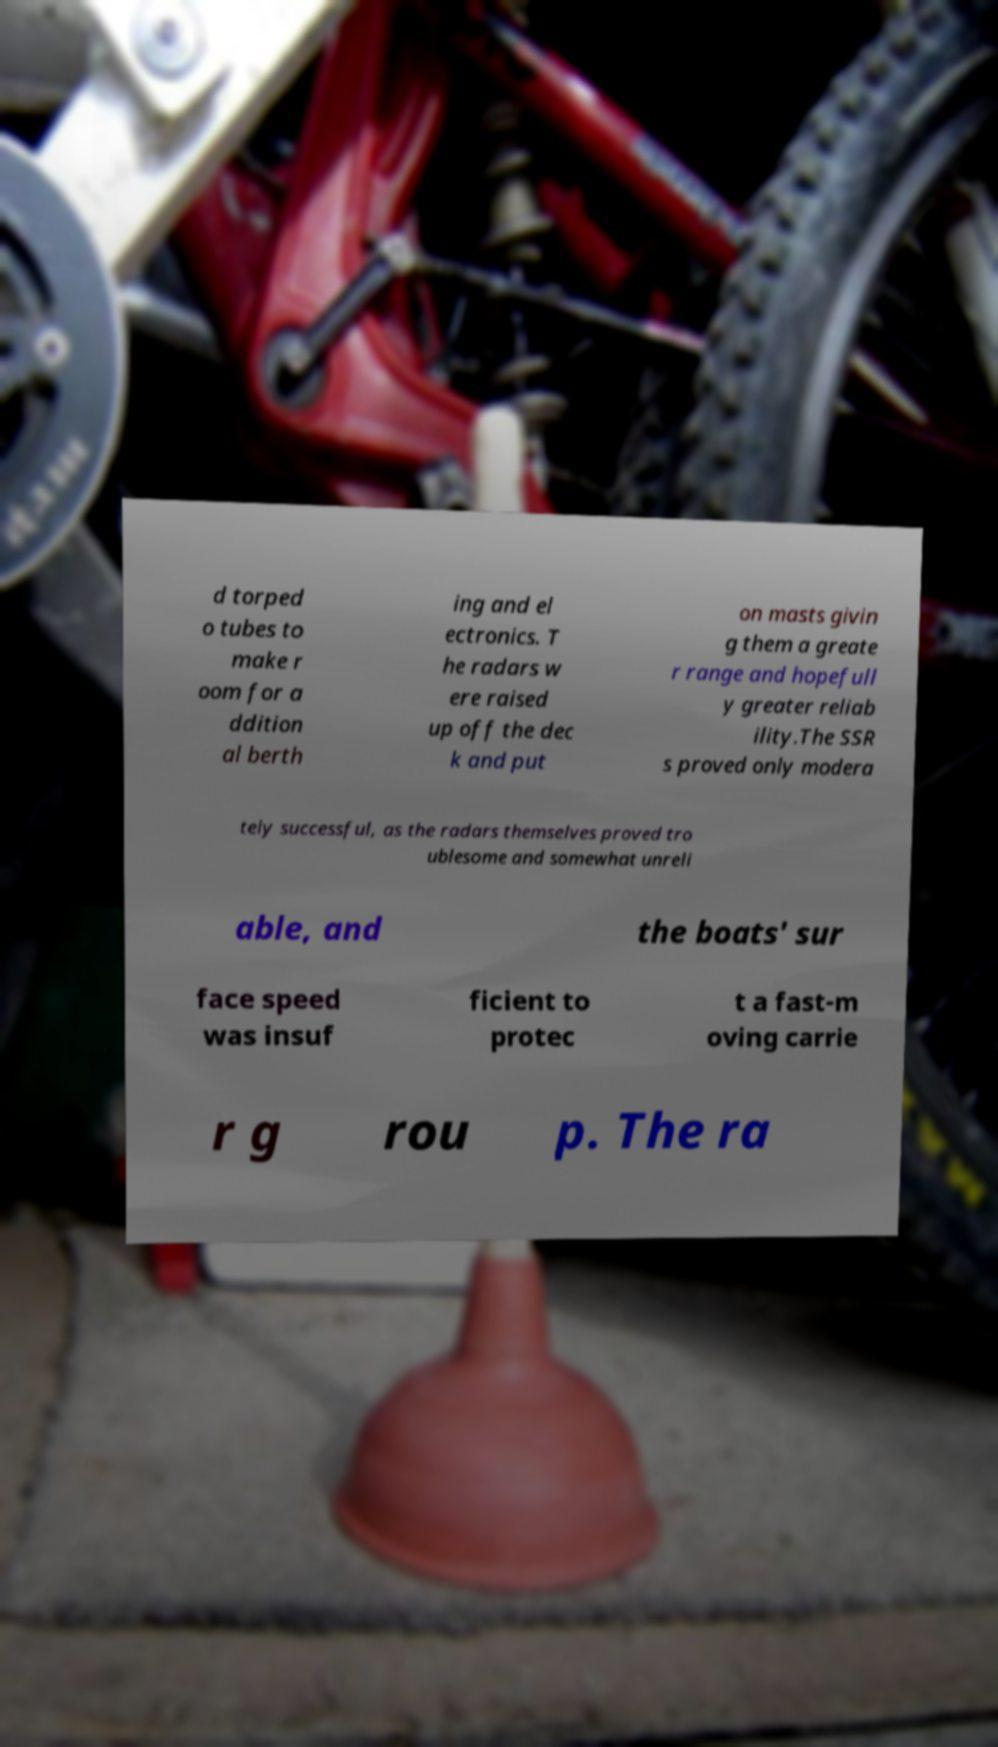Can you read and provide the text displayed in the image?This photo seems to have some interesting text. Can you extract and type it out for me? d torped o tubes to make r oom for a ddition al berth ing and el ectronics. T he radars w ere raised up off the dec k and put on masts givin g them a greate r range and hopefull y greater reliab ility.The SSR s proved only modera tely successful, as the radars themselves proved tro ublesome and somewhat unreli able, and the boats' sur face speed was insuf ficient to protec t a fast-m oving carrie r g rou p. The ra 